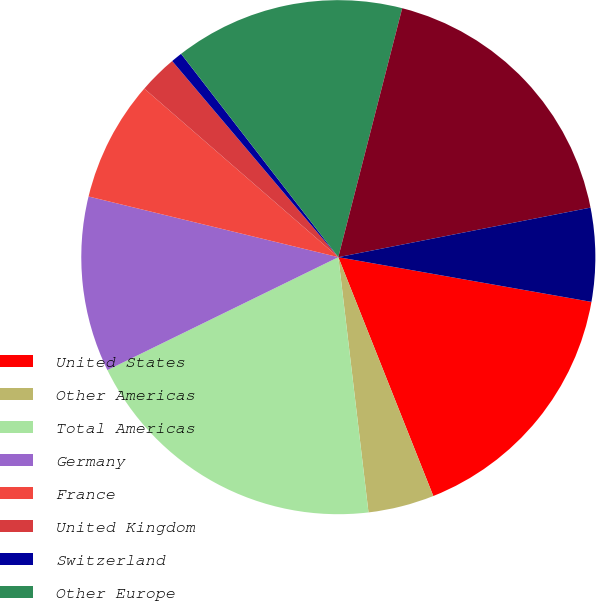Convert chart to OTSL. <chart><loc_0><loc_0><loc_500><loc_500><pie_chart><fcel>United States<fcel>Other Americas<fcel>Total Americas<fcel>Germany<fcel>France<fcel>United Kingdom<fcel>Switzerland<fcel>Other Europe<fcel>Total Europe<fcel>China<nl><fcel>16.19%<fcel>4.15%<fcel>19.63%<fcel>11.03%<fcel>7.59%<fcel>2.43%<fcel>0.71%<fcel>14.47%<fcel>17.91%<fcel>5.87%<nl></chart> 